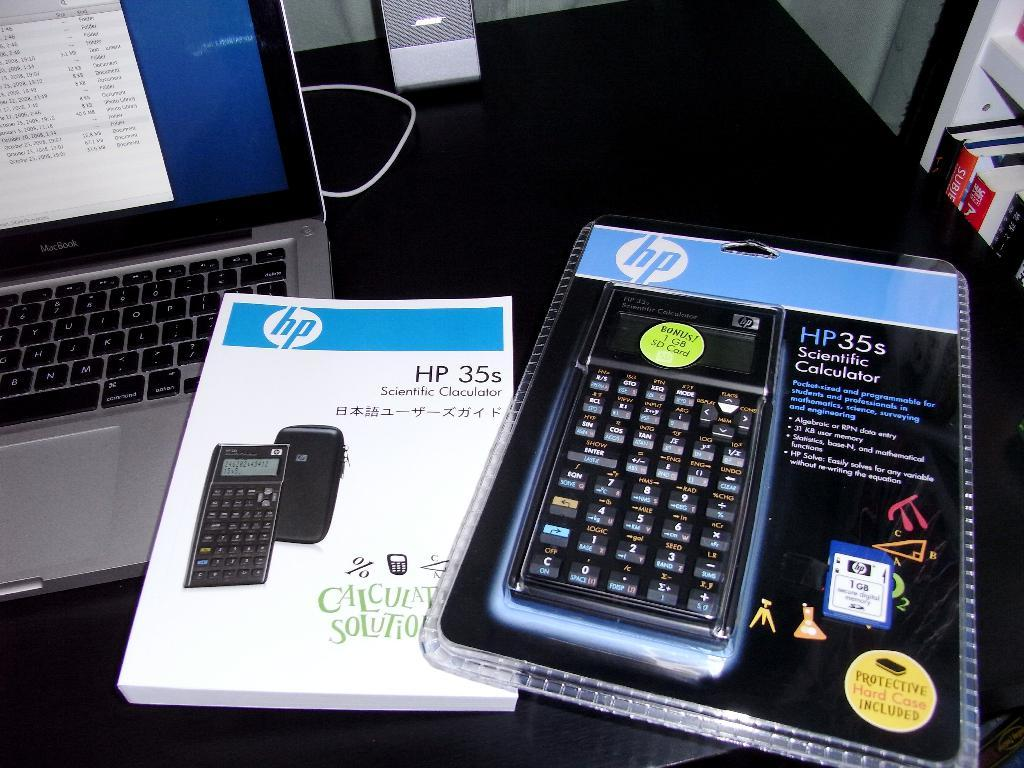Provide a one-sentence caption for the provided image. an HP35 scientific calculator still in the new packaging. 